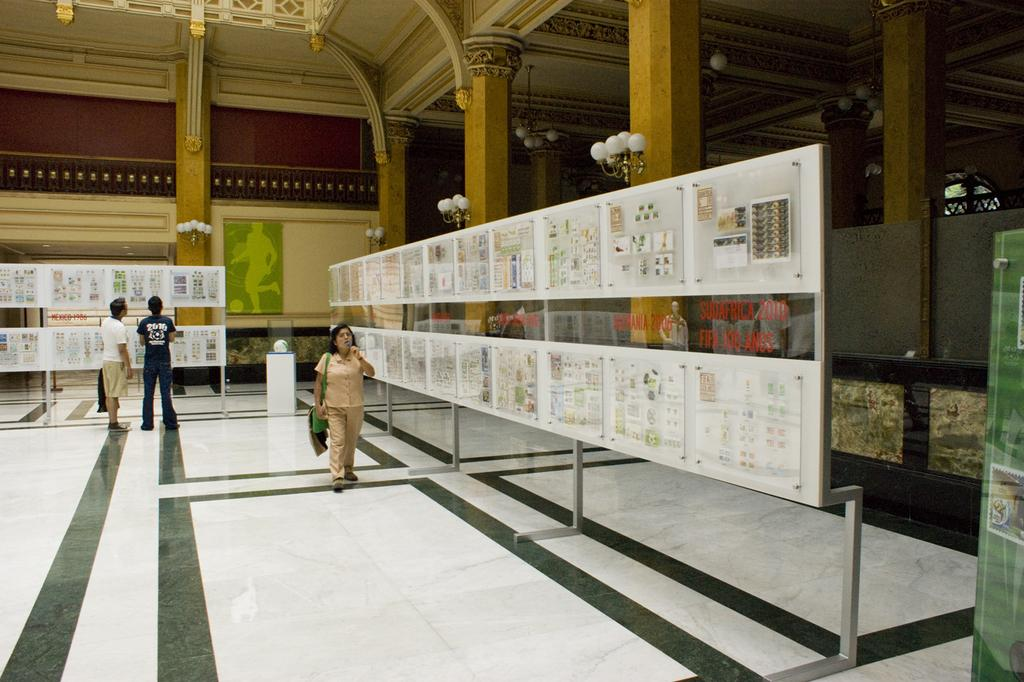How many people are in the image? There are three persons standing in the image. What are the papers attached to in the image? The papers are attached to glass boards in the image. What type of lighting is present in the image? There are lamps and a chandelier in the image. What architectural feature can be seen in the image? Pillars are present in the image. Are there any other objects visible in the image besides the people and the glass boards? Yes, there are other objects visible in the image. What type of oatmeal is being served in the image? There is no oatmeal present in the image. What nation is represented by the flag in the image? There is no flag visible in the image. 